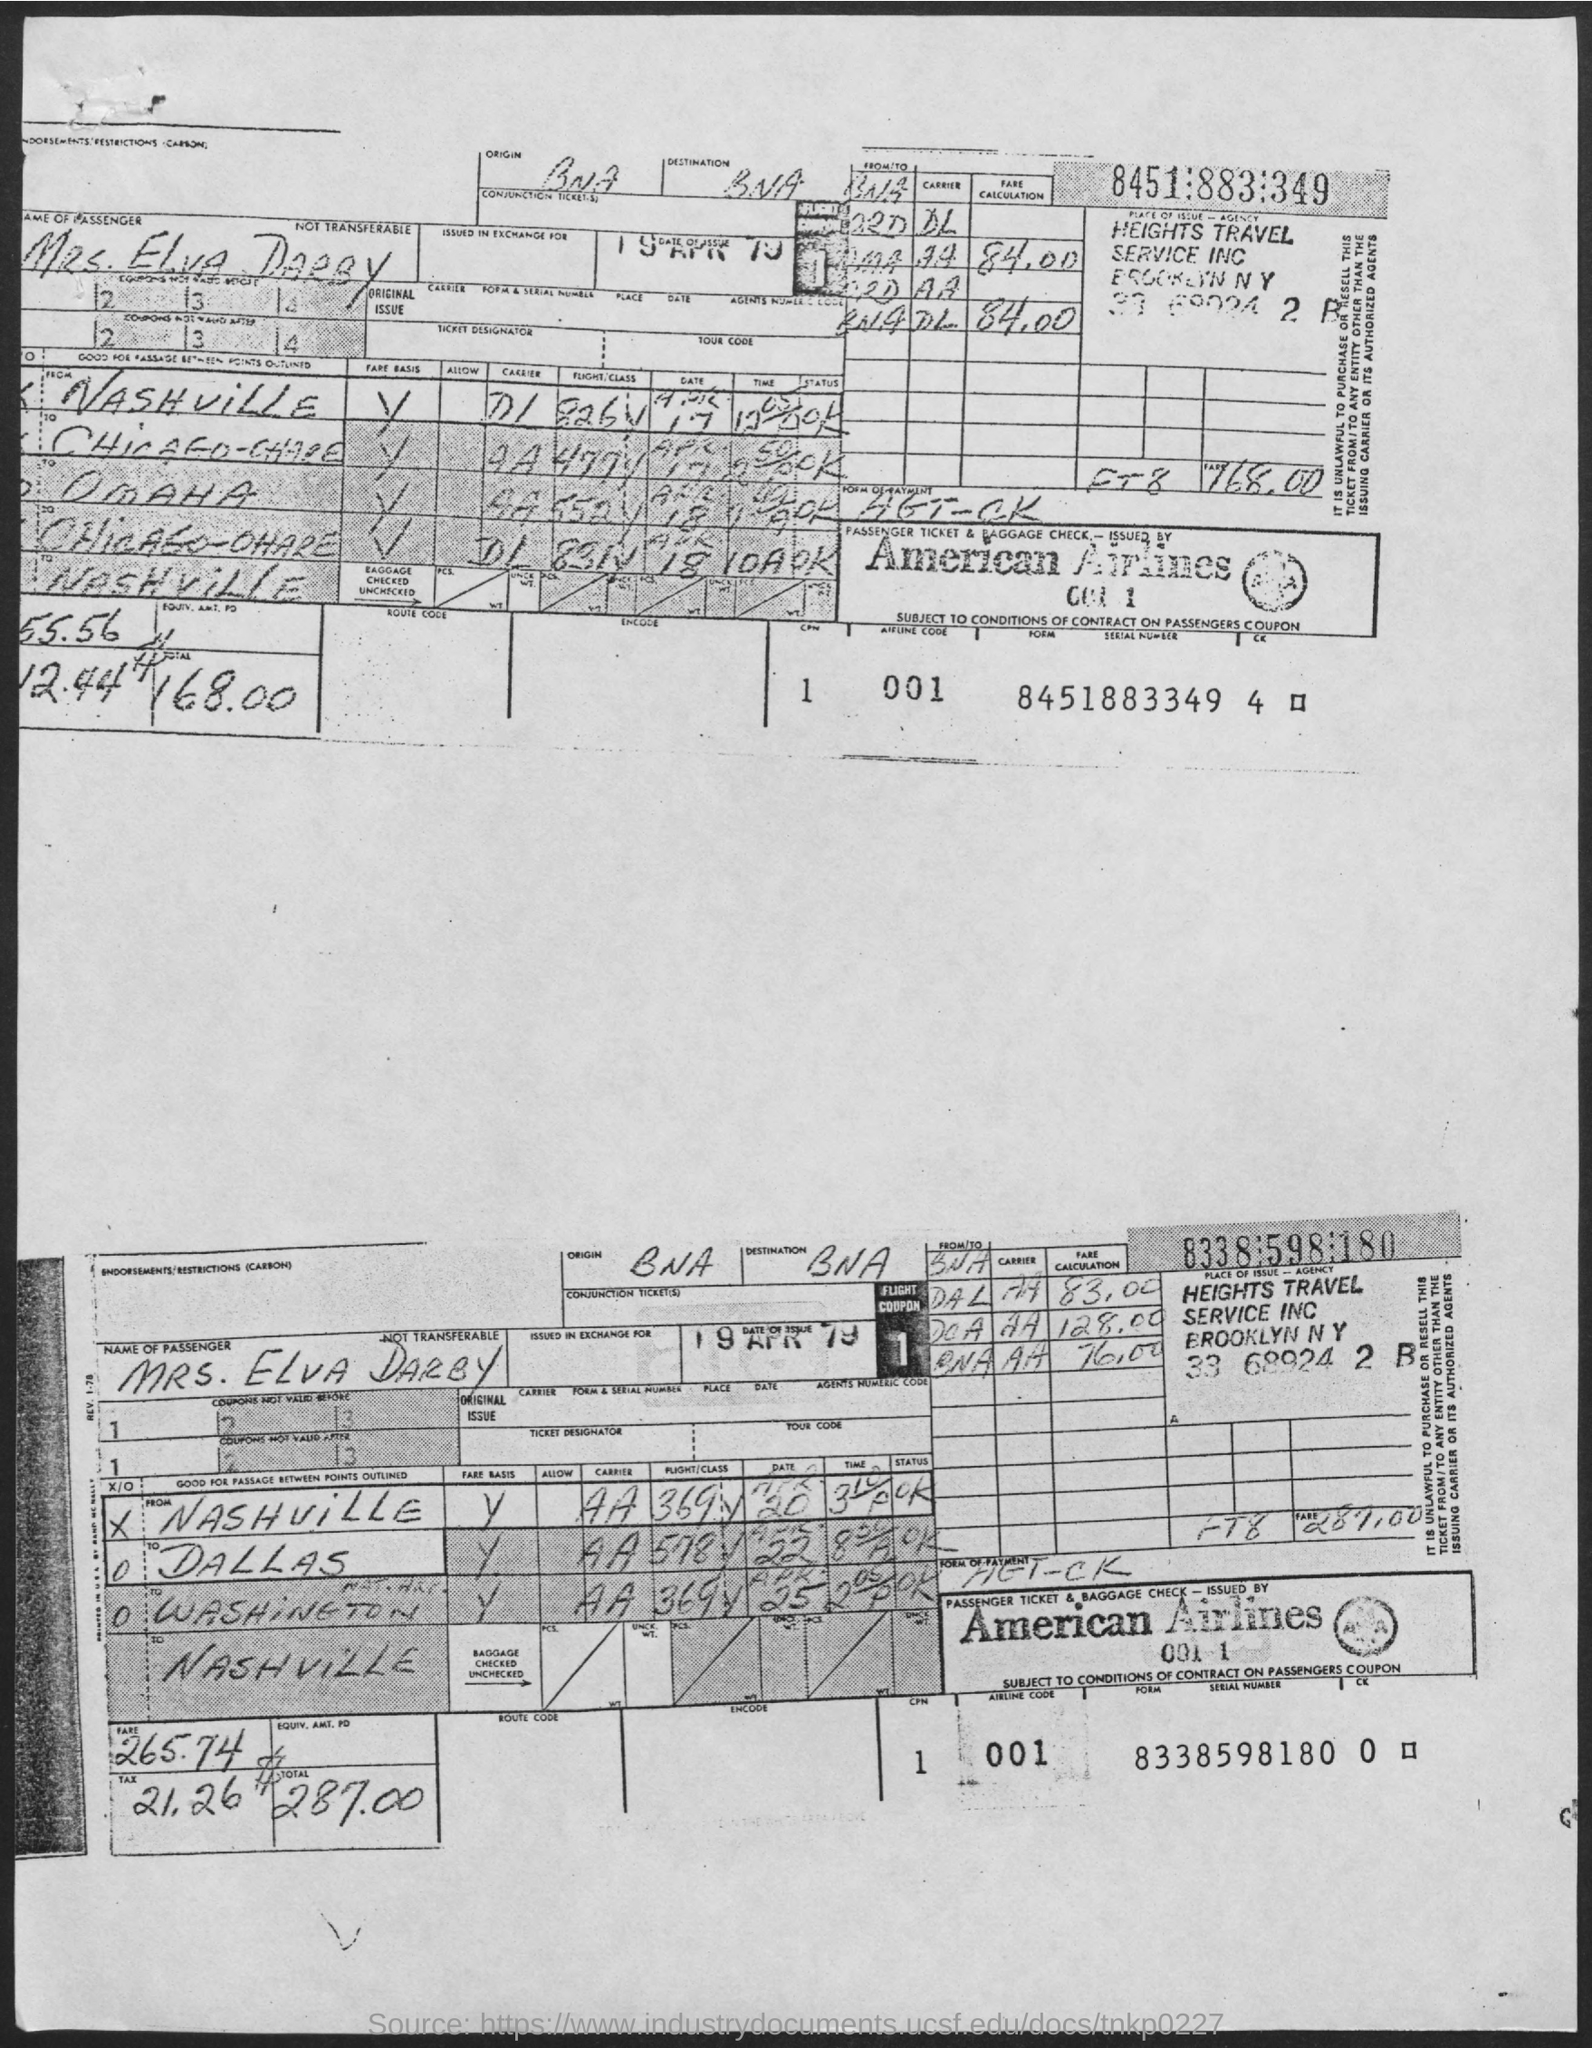What is the date of issue?
Give a very brief answer. 19 APR 79. 